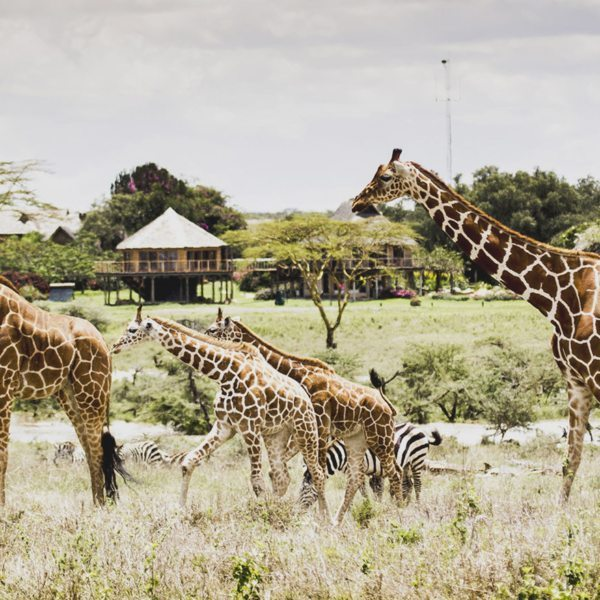Imagine! If the savanna could speak, what stories would it tell us about its history and inhabitants? If the savanna could speak, it would recount tales of ancient migrations, where vast herds of wildebeests and zebras journeyed across the plains in search of greener pastures. It would whisper about the balance of life and death, where the dance between predator and prey is both brutal and beautiful. The savanna would narrate the seasonal transformations, from lush, verdant expanses to dry, parched lands. It would honor the resilience of its inhabitants, from the towering giraffes to the stealthy leopards, each perfectly adapted to their environment. Finally, it would plea for preservation, echoing the importance of protecting this habitat for future generations. 